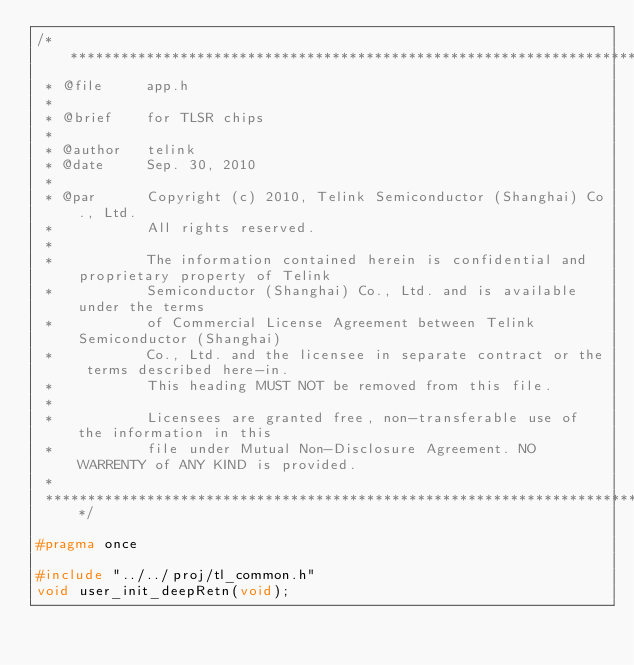<code> <loc_0><loc_0><loc_500><loc_500><_C_>/********************************************************************************************************
 * @file     app.h 
 *
 * @brief    for TLSR chips
 *
 * @author	 telink
 * @date     Sep. 30, 2010
 *
 * @par      Copyright (c) 2010, Telink Semiconductor (Shanghai) Co., Ltd.
 *           All rights reserved.
 *           
 *			 The information contained herein is confidential and proprietary property of Telink 
 * 		     Semiconductor (Shanghai) Co., Ltd. and is available under the terms 
 *			 of Commercial License Agreement between Telink Semiconductor (Shanghai) 
 *			 Co., Ltd. and the licensee in separate contract or the terms described here-in. 
 *           This heading MUST NOT be removed from this file.
 *
 * 			 Licensees are granted free, non-transferable use of the information in this 
 *			 file under Mutual Non-Disclosure Agreement. NO WARRENTY of ANY KIND is provided. 
 *           
 *******************************************************************************************************/

#pragma once

#include "../../proj/tl_common.h"
void user_init_deepRetn(void);

</code> 